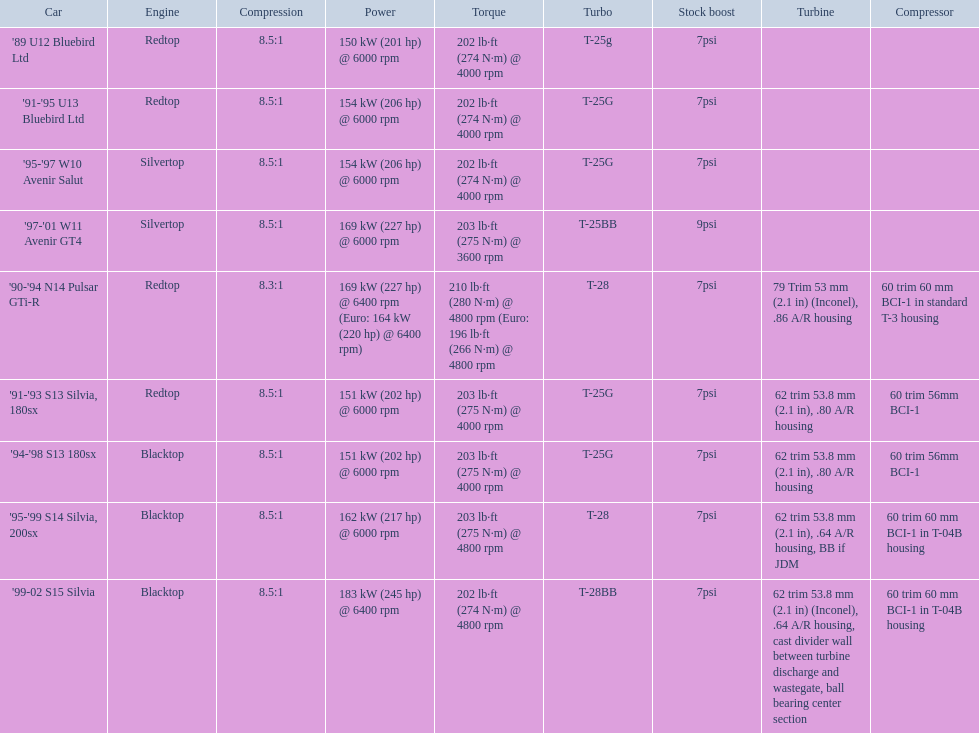Which car is the only one with more than 230 hp? '99-02 S15 Silvia. 